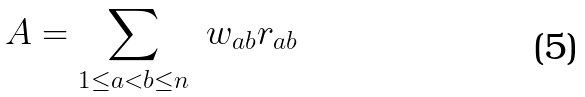Convert formula to latex. <formula><loc_0><loc_0><loc_500><loc_500>A = \sum _ { 1 \leq a < b \leq n } \ w _ { a b } r _ { a b }</formula> 